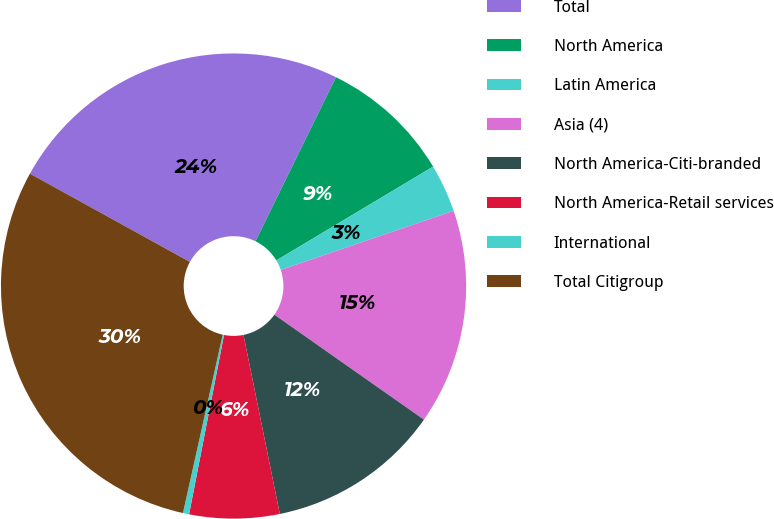Convert chart. <chart><loc_0><loc_0><loc_500><loc_500><pie_chart><fcel>Total<fcel>North America<fcel>Latin America<fcel>Asia (4)<fcel>North America-Citi-branded<fcel>North America-Retail services<fcel>International<fcel>Total Citigroup<nl><fcel>24.23%<fcel>9.16%<fcel>3.34%<fcel>14.98%<fcel>12.07%<fcel>6.25%<fcel>0.43%<fcel>29.53%<nl></chart> 